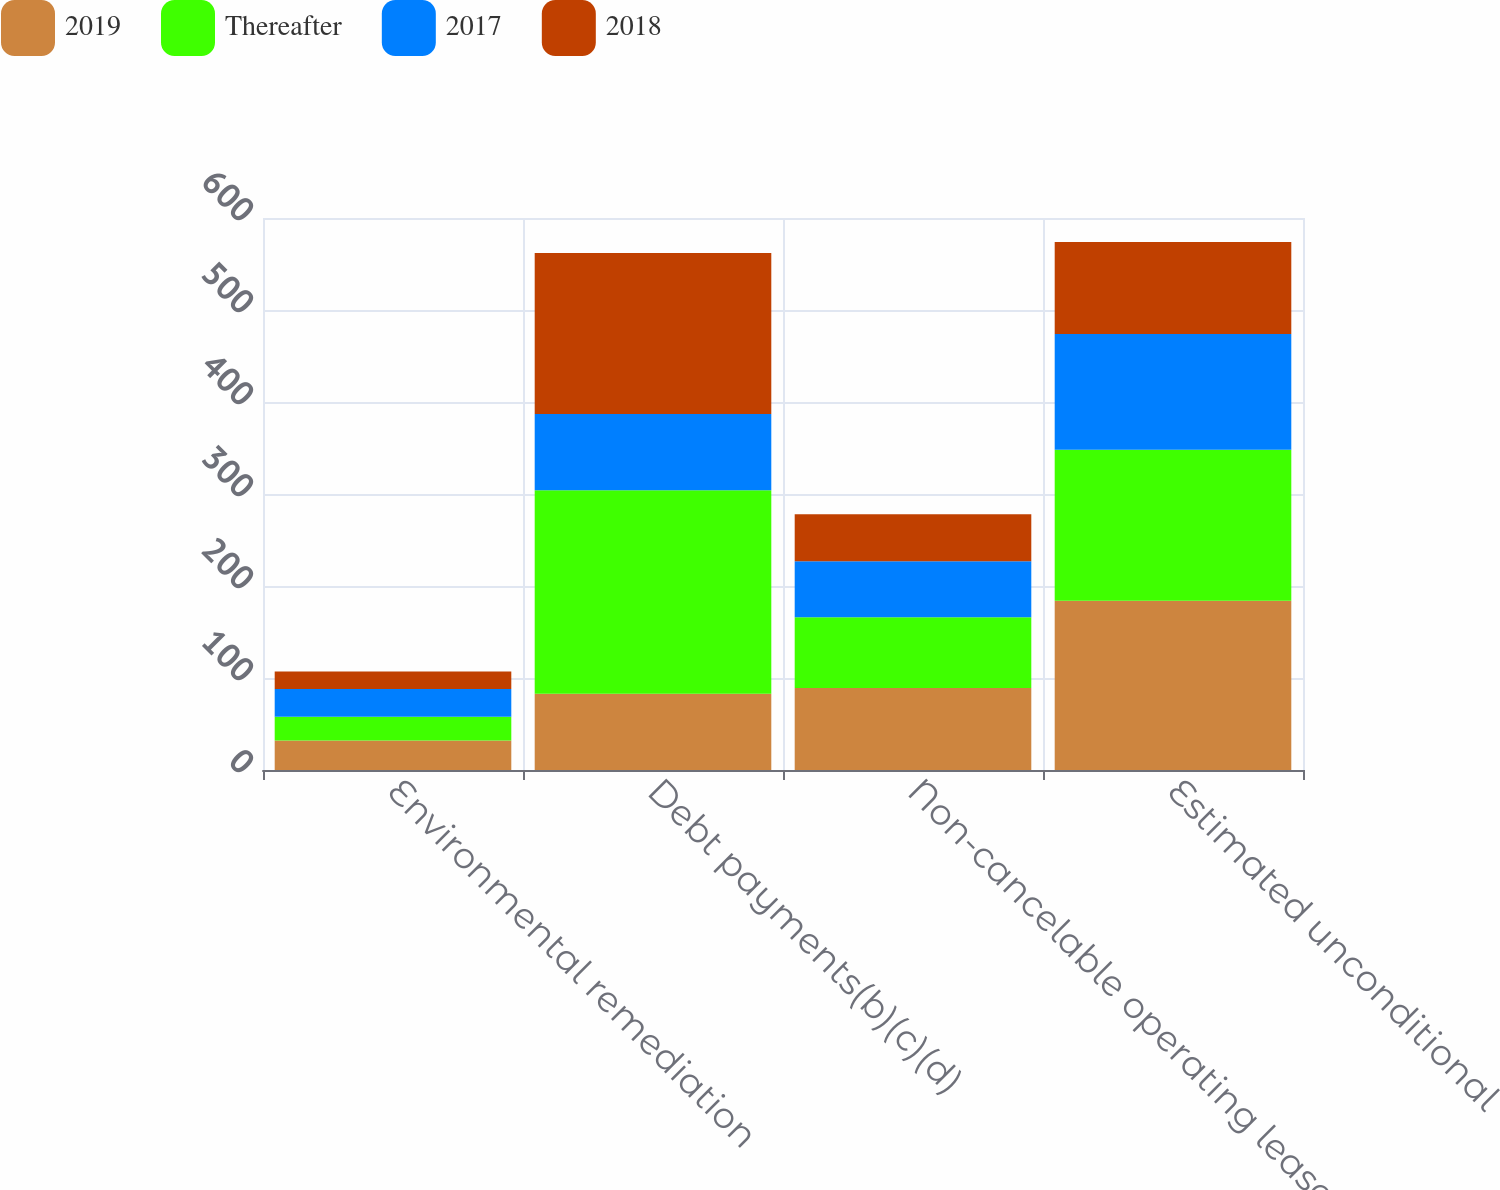Convert chart. <chart><loc_0><loc_0><loc_500><loc_500><stacked_bar_chart><ecel><fcel>Environmental remediation<fcel>Debt payments(b)(c)(d)<fcel>Non-cancelable operating lease<fcel>Estimated unconditional<nl><fcel>2019<fcel>32<fcel>83<fcel>89<fcel>184<nl><fcel>Thereafter<fcel>26<fcel>221<fcel>77<fcel>164<nl><fcel>2017<fcel>30<fcel>83<fcel>61<fcel>126<nl><fcel>2018<fcel>19<fcel>175<fcel>51<fcel>100<nl></chart> 